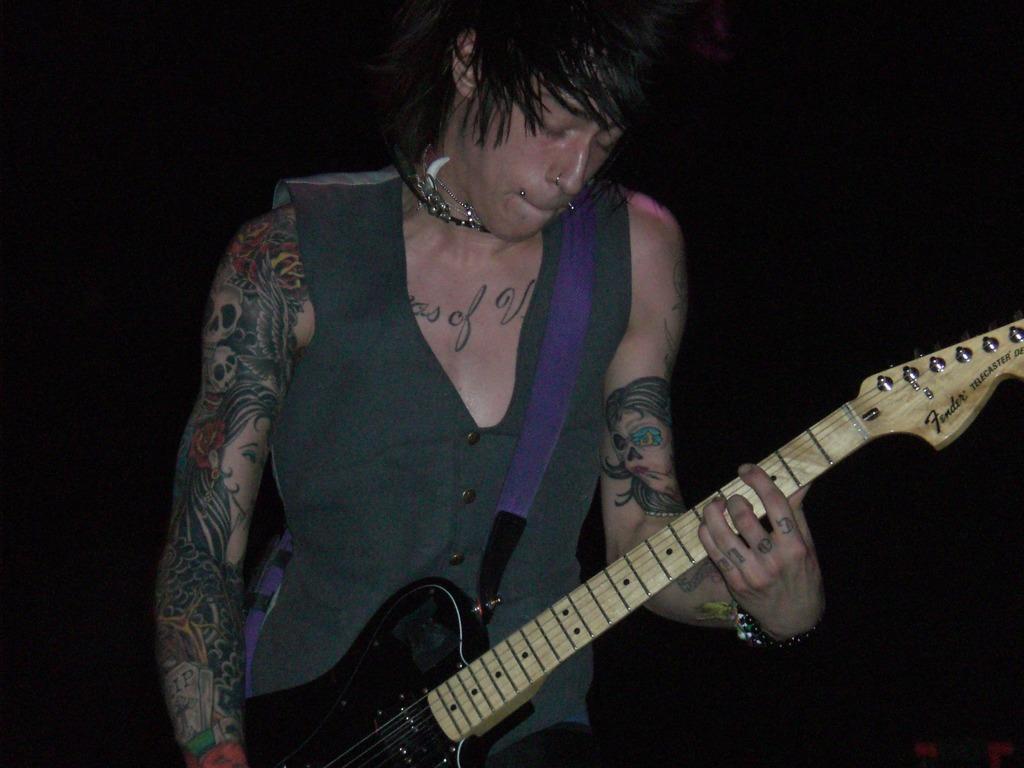How would you summarize this image in a sentence or two? A man is playing a guitar. 